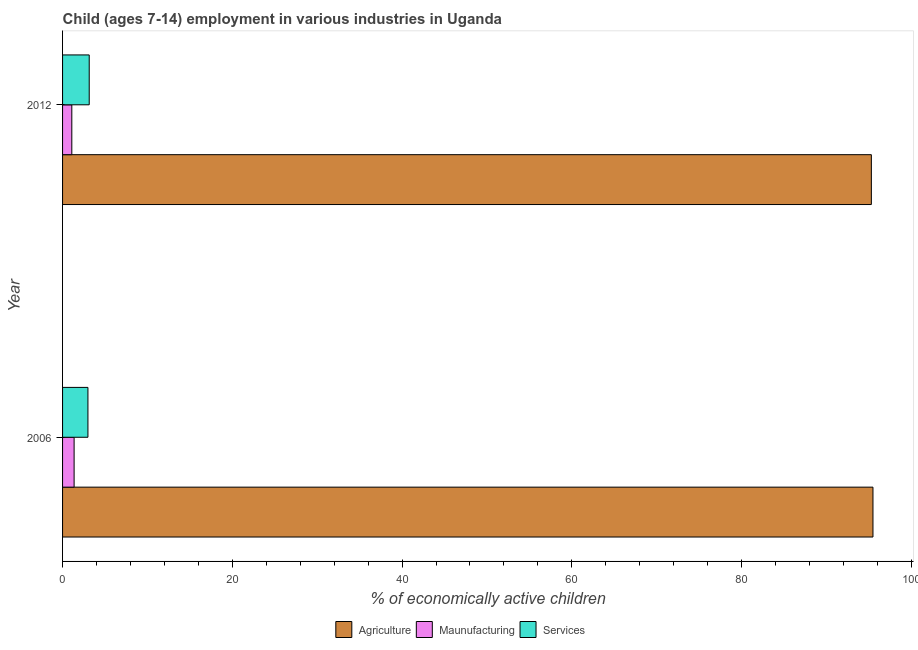How many different coloured bars are there?
Make the answer very short. 3. How many bars are there on the 2nd tick from the top?
Your answer should be very brief. 3. What is the percentage of economically active children in agriculture in 2012?
Give a very brief answer. 95.29. Across all years, what is the maximum percentage of economically active children in agriculture?
Your answer should be compact. 95.48. Across all years, what is the minimum percentage of economically active children in services?
Keep it short and to the point. 2.99. What is the total percentage of economically active children in services in the graph?
Give a very brief answer. 6.13. What is the difference between the percentage of economically active children in manufacturing in 2006 and that in 2012?
Your answer should be compact. 0.27. What is the difference between the percentage of economically active children in manufacturing in 2006 and the percentage of economically active children in agriculture in 2012?
Provide a succinct answer. -93.93. What is the average percentage of economically active children in agriculture per year?
Your response must be concise. 95.39. In the year 2006, what is the difference between the percentage of economically active children in agriculture and percentage of economically active children in manufacturing?
Your answer should be very brief. 94.12. In how many years, is the percentage of economically active children in manufacturing greater than 88 %?
Your answer should be very brief. 0. What is the ratio of the percentage of economically active children in manufacturing in 2006 to that in 2012?
Give a very brief answer. 1.25. What does the 1st bar from the top in 2012 represents?
Provide a short and direct response. Services. What does the 1st bar from the bottom in 2012 represents?
Offer a terse response. Agriculture. Are all the bars in the graph horizontal?
Give a very brief answer. Yes. What is the difference between two consecutive major ticks on the X-axis?
Provide a short and direct response. 20. Are the values on the major ticks of X-axis written in scientific E-notation?
Offer a terse response. No. Does the graph contain grids?
Offer a terse response. No. What is the title of the graph?
Give a very brief answer. Child (ages 7-14) employment in various industries in Uganda. Does "Labor Tax" appear as one of the legend labels in the graph?
Provide a short and direct response. No. What is the label or title of the X-axis?
Make the answer very short. % of economically active children. What is the label or title of the Y-axis?
Offer a very short reply. Year. What is the % of economically active children of Agriculture in 2006?
Provide a short and direct response. 95.48. What is the % of economically active children of Maunufacturing in 2006?
Your answer should be compact. 1.36. What is the % of economically active children in Services in 2006?
Keep it short and to the point. 2.99. What is the % of economically active children in Agriculture in 2012?
Give a very brief answer. 95.29. What is the % of economically active children in Maunufacturing in 2012?
Offer a very short reply. 1.09. What is the % of economically active children in Services in 2012?
Offer a very short reply. 3.14. Across all years, what is the maximum % of economically active children of Agriculture?
Your response must be concise. 95.48. Across all years, what is the maximum % of economically active children in Maunufacturing?
Your answer should be very brief. 1.36. Across all years, what is the maximum % of economically active children in Services?
Provide a short and direct response. 3.14. Across all years, what is the minimum % of economically active children in Agriculture?
Your answer should be compact. 95.29. Across all years, what is the minimum % of economically active children in Maunufacturing?
Offer a very short reply. 1.09. Across all years, what is the minimum % of economically active children in Services?
Your answer should be very brief. 2.99. What is the total % of economically active children of Agriculture in the graph?
Make the answer very short. 190.77. What is the total % of economically active children of Maunufacturing in the graph?
Give a very brief answer. 2.45. What is the total % of economically active children of Services in the graph?
Provide a short and direct response. 6.13. What is the difference between the % of economically active children in Agriculture in 2006 and that in 2012?
Provide a short and direct response. 0.19. What is the difference between the % of economically active children in Maunufacturing in 2006 and that in 2012?
Your answer should be very brief. 0.27. What is the difference between the % of economically active children of Agriculture in 2006 and the % of economically active children of Maunufacturing in 2012?
Your answer should be compact. 94.39. What is the difference between the % of economically active children in Agriculture in 2006 and the % of economically active children in Services in 2012?
Provide a short and direct response. 92.34. What is the difference between the % of economically active children in Maunufacturing in 2006 and the % of economically active children in Services in 2012?
Provide a succinct answer. -1.78. What is the average % of economically active children of Agriculture per year?
Ensure brevity in your answer.  95.39. What is the average % of economically active children of Maunufacturing per year?
Make the answer very short. 1.23. What is the average % of economically active children of Services per year?
Ensure brevity in your answer.  3.06. In the year 2006, what is the difference between the % of economically active children of Agriculture and % of economically active children of Maunufacturing?
Give a very brief answer. 94.12. In the year 2006, what is the difference between the % of economically active children in Agriculture and % of economically active children in Services?
Your response must be concise. 92.49. In the year 2006, what is the difference between the % of economically active children in Maunufacturing and % of economically active children in Services?
Make the answer very short. -1.63. In the year 2012, what is the difference between the % of economically active children in Agriculture and % of economically active children in Maunufacturing?
Your response must be concise. 94.2. In the year 2012, what is the difference between the % of economically active children in Agriculture and % of economically active children in Services?
Offer a terse response. 92.15. In the year 2012, what is the difference between the % of economically active children of Maunufacturing and % of economically active children of Services?
Ensure brevity in your answer.  -2.05. What is the ratio of the % of economically active children in Maunufacturing in 2006 to that in 2012?
Make the answer very short. 1.25. What is the ratio of the % of economically active children of Services in 2006 to that in 2012?
Offer a very short reply. 0.95. What is the difference between the highest and the second highest % of economically active children of Agriculture?
Provide a short and direct response. 0.19. What is the difference between the highest and the second highest % of economically active children in Maunufacturing?
Your response must be concise. 0.27. What is the difference between the highest and the lowest % of economically active children of Agriculture?
Ensure brevity in your answer.  0.19. What is the difference between the highest and the lowest % of economically active children of Maunufacturing?
Your response must be concise. 0.27. What is the difference between the highest and the lowest % of economically active children in Services?
Your response must be concise. 0.15. 